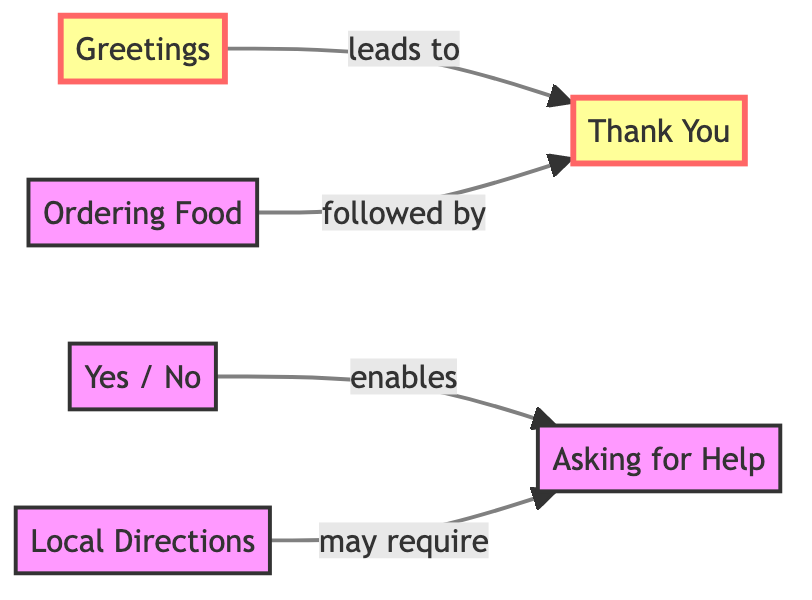What are the nodes in the diagram? The nodes are the key phrases: Greetings, Thank You, Yes / No, Asking for Help, Ordering Food, and Local Directions.
Answer: Greetings, Thank You, Yes / No, Asking for Help, Ordering Food, Local Directions How many edges are present in the diagram? There are 4 edges connecting the nodes: Greetings to Thank You, Yes / No to Asking for Help, Ordering Food to Thank You, and Local Directions to Asking for Help.
Answer: 4 Which node leads to "Thank You"? The edges from the diagram indicate that "Greetings" and "Ordering Food" both lead to "Thank You".
Answer: Greetings, Ordering Food What is the relationship between "Yes / No" and "Asking for Help"? The edge from "Yes / No" to "Asking for Help" indicates that affirmations and negations (Yes / No) enable the ability to Ask for Help.
Answer: enables Which nodes may require "Asking for Help"? The diagram shows that "Local Directions" may require "Asking for Help" based on the connecting edge.
Answer: Local Directions What is the starting point for the communication flow? The starting point in the diagram is the "Greetings" node, as it leads to "Thank You".
Answer: Greetings If someone uses "Ordering Food", what should they express after? After using "Ordering Food", the individual is expected to express "Thank You", as shown by the connection in the diagram.
Answer: Thank You Identify a connection that doesn't involve "Thank You". The connection from "Yes / No" to "Asking for Help" is a valid relationship that does not include "Thank You".
Answer: Yes / No to Asking for Help How does "Local Directions" connect with other nodes? "Local Directions" connects to "Asking for Help", highlighting the importance of requesting assistance when seeking directions.
Answer: Asking for Help 